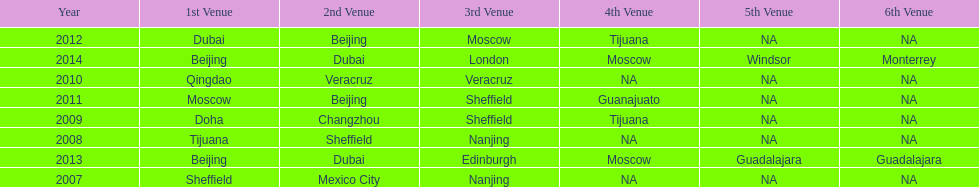Could you help me parse every detail presented in this table? {'header': ['Year', '1st Venue', '2nd Venue', '3rd Venue', '4th Venue', '5th Venue', '6th Venue'], 'rows': [['2012', 'Dubai', 'Beijing', 'Moscow', 'Tijuana', 'NA', 'NA'], ['2014', 'Beijing', 'Dubai', 'London', 'Moscow', 'Windsor', 'Monterrey'], ['2010', 'Qingdao', 'Veracruz', 'Veracruz', 'NA', 'NA', 'NA'], ['2011', 'Moscow', 'Beijing', 'Sheffield', 'Guanajuato', 'NA', 'NA'], ['2009', 'Doha', 'Changzhou', 'Sheffield', 'Tijuana', 'NA', 'NA'], ['2008', 'Tijuana', 'Sheffield', 'Nanjing', 'NA', 'NA', 'NA'], ['2013', 'Beijing', 'Dubai', 'Edinburgh', 'Moscow', 'Guadalajara', 'Guadalajara'], ['2007', 'Sheffield', 'Mexico City', 'Nanjing', 'NA', 'NA', 'NA']]} What was the last year where tijuana was a venue? 2012. 